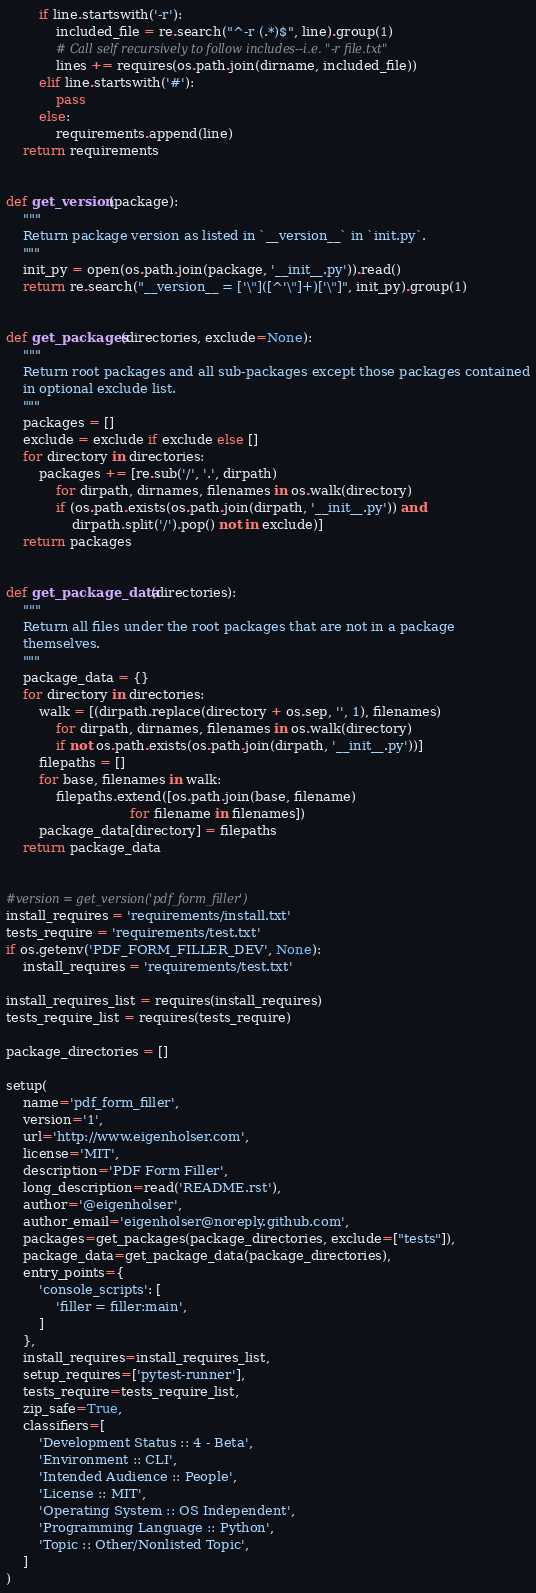Convert code to text. <code><loc_0><loc_0><loc_500><loc_500><_Python_>        if line.startswith('-r'):
            included_file = re.search("^-r (.*)$", line).group(1)
            # Call self recursively to follow includes--i.e. "-r file.txt"
            lines += requires(os.path.join(dirname, included_file))
        elif line.startswith('#'):
            pass
        else:
            requirements.append(line)
    return requirements


def get_version(package):
    """
    Return package version as listed in `__version__` in `init.py`.
    """
    init_py = open(os.path.join(package, '__init__.py')).read()
    return re.search("__version__ = ['\"]([^'\"]+)['\"]", init_py).group(1)


def get_packages(directories, exclude=None):
    """
    Return root packages and all sub-packages except those packages contained
    in optional exclude list.
    """
    packages = []
    exclude = exclude if exclude else []
    for directory in directories:
        packages += [re.sub('/', '.', dirpath)
            for dirpath, dirnames, filenames in os.walk(directory)
            if (os.path.exists(os.path.join(dirpath, '__init__.py')) and
                dirpath.split('/').pop() not in exclude)]
    return packages


def get_package_data(directories):
    """
    Return all files under the root packages that are not in a package
    themselves.
    """
    package_data = {}
    for directory in directories:
        walk = [(dirpath.replace(directory + os.sep, '', 1), filenames)
            for dirpath, dirnames, filenames in os.walk(directory)
            if not os.path.exists(os.path.join(dirpath, '__init__.py'))]
        filepaths = []
        for base, filenames in walk:
            filepaths.extend([os.path.join(base, filename)
                              for filename in filenames])
        package_data[directory] = filepaths
    return package_data


#version = get_version('pdf_form_filler')
install_requires = 'requirements/install.txt'
tests_require = 'requirements/test.txt'
if os.getenv('PDF_FORM_FILLER_DEV', None):
    install_requires = 'requirements/test.txt'

install_requires_list = requires(install_requires)
tests_require_list = requires(tests_require)

package_directories = []

setup(
    name='pdf_form_filler',
    version='1',
    url='http://www.eigenholser.com',
    license='MIT',
    description='PDF Form Filler',
    long_description=read('README.rst'),
    author='@eigenholser',
    author_email='eigenholser@noreply.github.com',
    packages=get_packages(package_directories, exclude=["tests"]),
    package_data=get_package_data(package_directories),
    entry_points={
        'console_scripts': [
            'filler = filler:main',
        ]
    },
    install_requires=install_requires_list,
    setup_requires=['pytest-runner'],
    tests_require=tests_require_list,
    zip_safe=True,
    classifiers=[
        'Development Status :: 4 - Beta',
        'Environment :: CLI',
        'Intended Audience :: People',
        'License :: MIT',
        'Operating System :: OS Independent',
        'Programming Language :: Python',
        'Topic :: Other/Nonlisted Topic',
    ]
)

</code> 